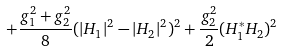<formula> <loc_0><loc_0><loc_500><loc_500>+ \frac { g ^ { 2 } _ { 1 } + g ^ { 2 } _ { 2 } } { 8 } ( | H _ { 1 } | ^ { 2 } - | H _ { 2 } | ^ { 2 } ) ^ { 2 } + \frac { g ^ { 2 } _ { 2 } } { 2 } ( H ^ { * } _ { 1 } H _ { 2 } ) ^ { 2 }</formula> 